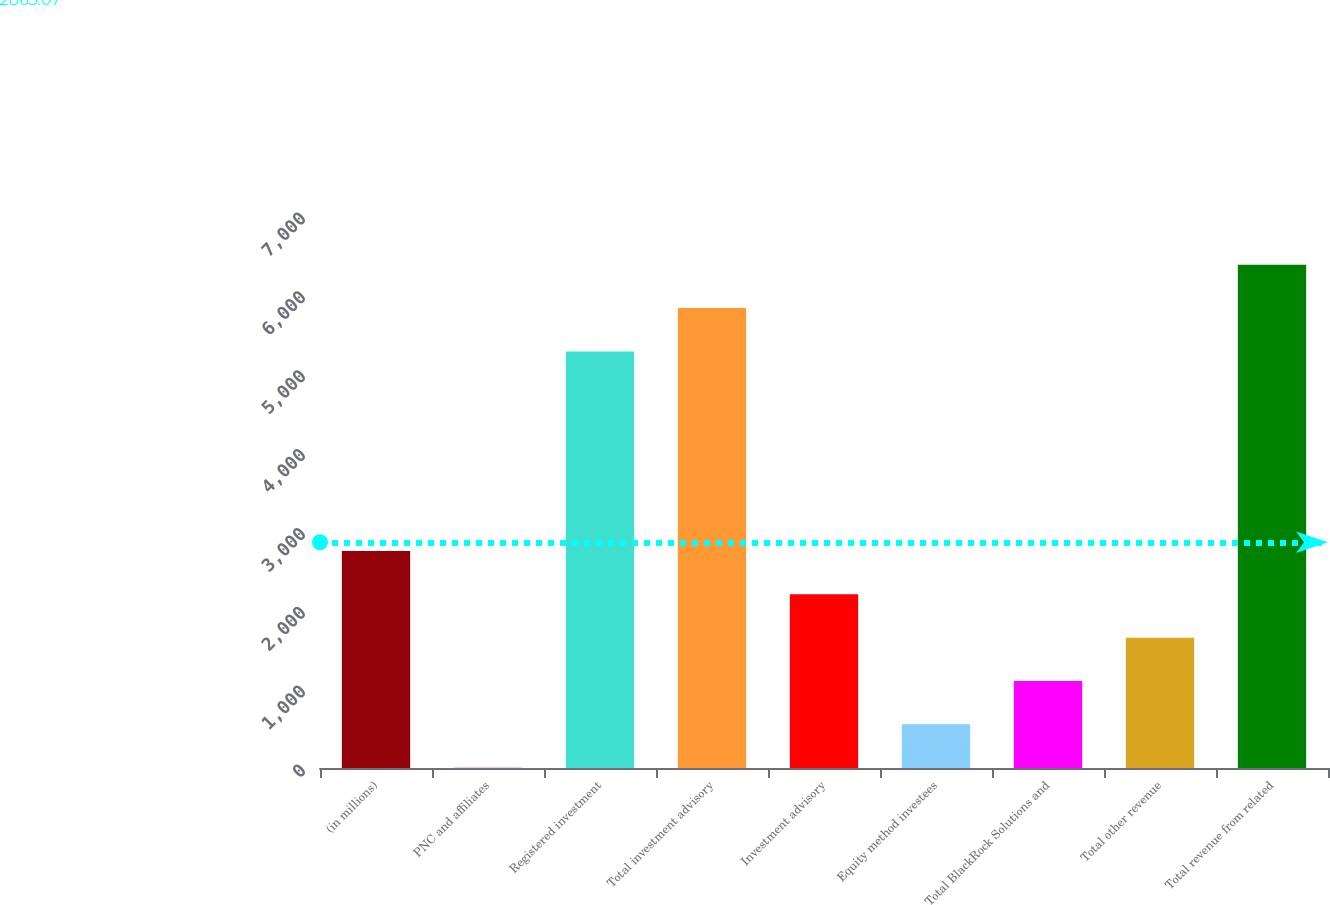Convert chart. <chart><loc_0><loc_0><loc_500><loc_500><bar_chart><fcel>(in millions)<fcel>PNC and affiliates<fcel>Registered investment<fcel>Total investment advisory<fcel>Investment advisory<fcel>Equity method investees<fcel>Total BlackRock Solutions and<fcel>Total other revenue<fcel>Total revenue from related<nl><fcel>2752.5<fcel>4<fcel>5283<fcel>5832.7<fcel>2202.8<fcel>553.7<fcel>1103.4<fcel>1653.1<fcel>6382.4<nl></chart> 